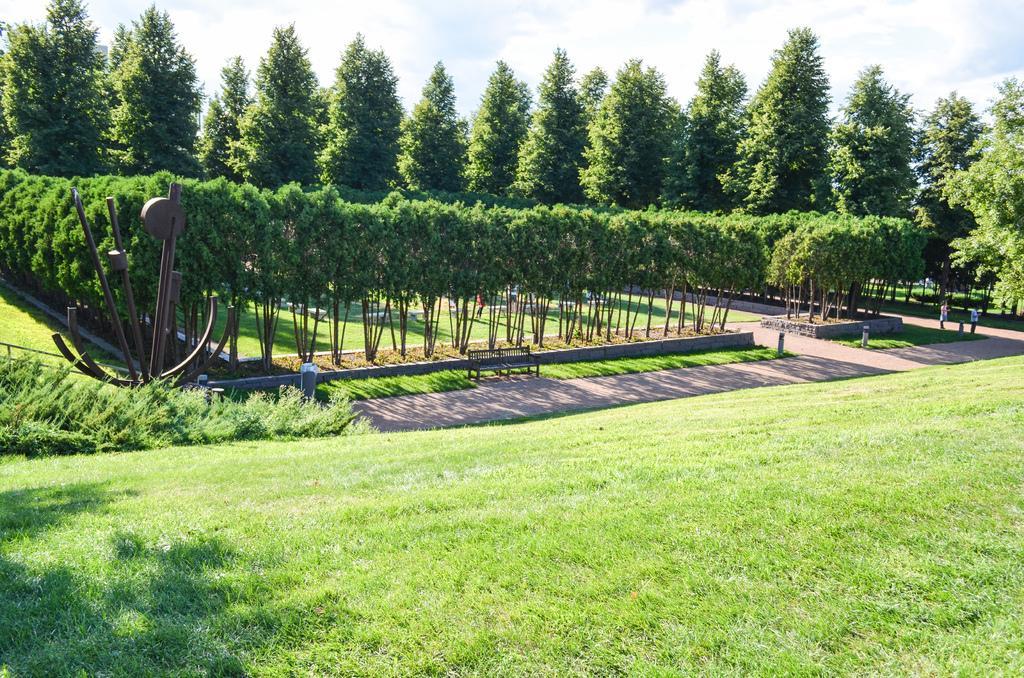Please provide a concise description of this image. In this image there is grass on the ground in the center. In the background there are trees and the sky is cloudy and there is an empty bench in the center and there are persons. 